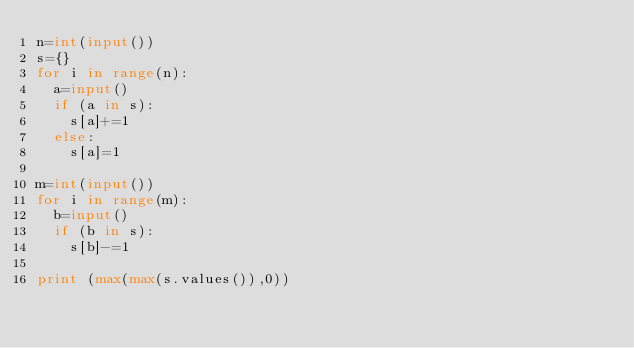<code> <loc_0><loc_0><loc_500><loc_500><_Python_>n=int(input())
s={}
for i in range(n):
  a=input()
  if (a in s):
    s[a]+=1
  else:
    s[a]=1
  
m=int(input())
for i in range(m):
  b=input()
  if (b in s):
    s[b]-=1
  
print (max(max(s.values()),0))</code> 